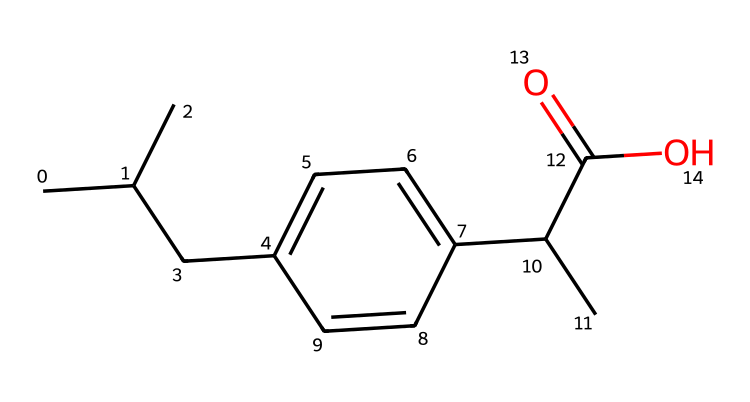how many carbon atoms are in ibuprofen? By analyzing the SMILES representation, we count the carbon atoms directly. Each 'C' in the SMILES represents a carbon atom. In the given structure, there are eleven 'C' characters, indicating eleven carbon atoms.
Answer: eleven what is the functional group present in ibuprofen? The presence of the "C(=O)O" part of the SMILES indicates that there is a carboxylic acid functional group. The "C(=O)" shows a carbon atom double-bonded to an oxygen atom and single-bonded to an -OH group typically associated with carboxylic acids.
Answer: carboxylic acid how many hydrogen atoms are in ibuprofen? Each carbon typically forms four bonds, and we can assume typical hydrogen counts for the terminal and branched carbons. Considering all carbons and the functional group with one -OH, we deduce that the total number of hydrogen atoms is 14.
Answer: fourteen what type of drug is ibuprofen classified as? Ibuprofen is classified as a nonsteroidal anti-inflammatory drug (NSAID) due to its structural properties that relate to its anti-inflammatory and analgesic effects.
Answer: NSAID what is the molecular weight of ibuprofen? To calculate the molecular weight, we need to sum the atomic weights of all the atoms present in the structure: 11 carbons (11×12.01), 14 hydrogens (14×1.008), 2 oxygens (2×16.00). The sum gives a molecular weight of approximately 206.29 grams per mole.
Answer: 206.29 which part of the structure contributes to the anti-inflammatory properties of ibuprofen? The carboxylic acid functional group contributes to the anti-inflammatory properties, as it is crucial for the drug's interaction with cyclooxygenase enzymes to inhibit the synthesis of prostaglandins, which mediate inflammation.
Answer: carboxylic acid is ibuprofen a chiral molecule? A chiral molecule must have an asymmetric carbon—one that is bonded to four different groups. In ibuprofen’s structure, there is one chiral carbon atom (the one connected to the –COOH and two alkyl groups), indicating that the molecule is chiral.
Answer: yes 